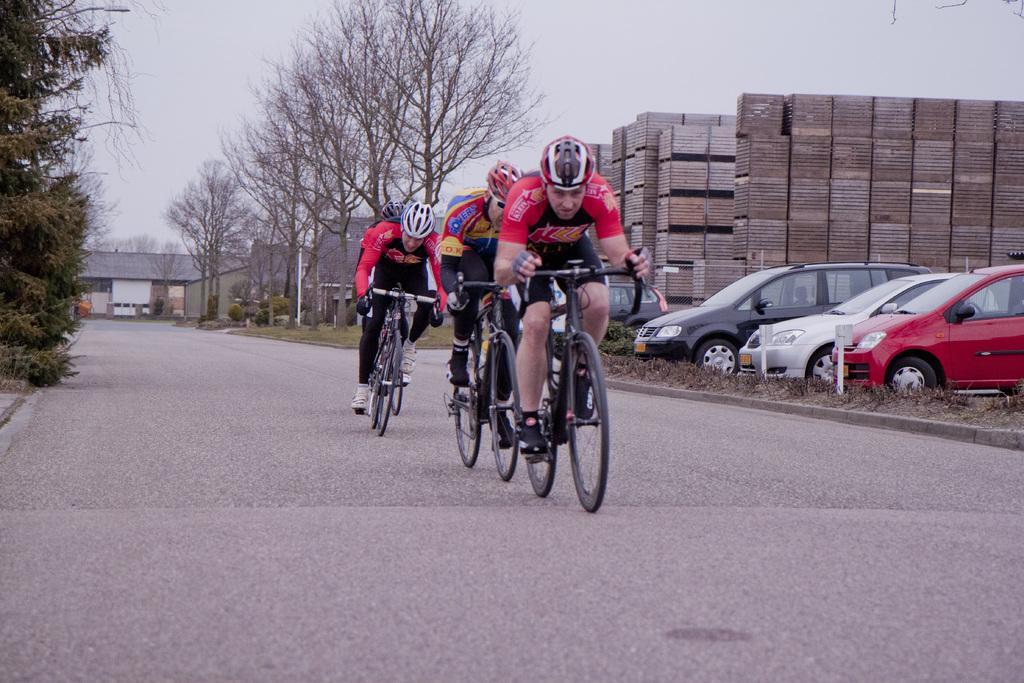Can you describe this image briefly? In this picture there are people in the center of the image, they are cycling and there are cars and trees in the image, it seems to be, there are wooden crates and houses in the background area of the image. 